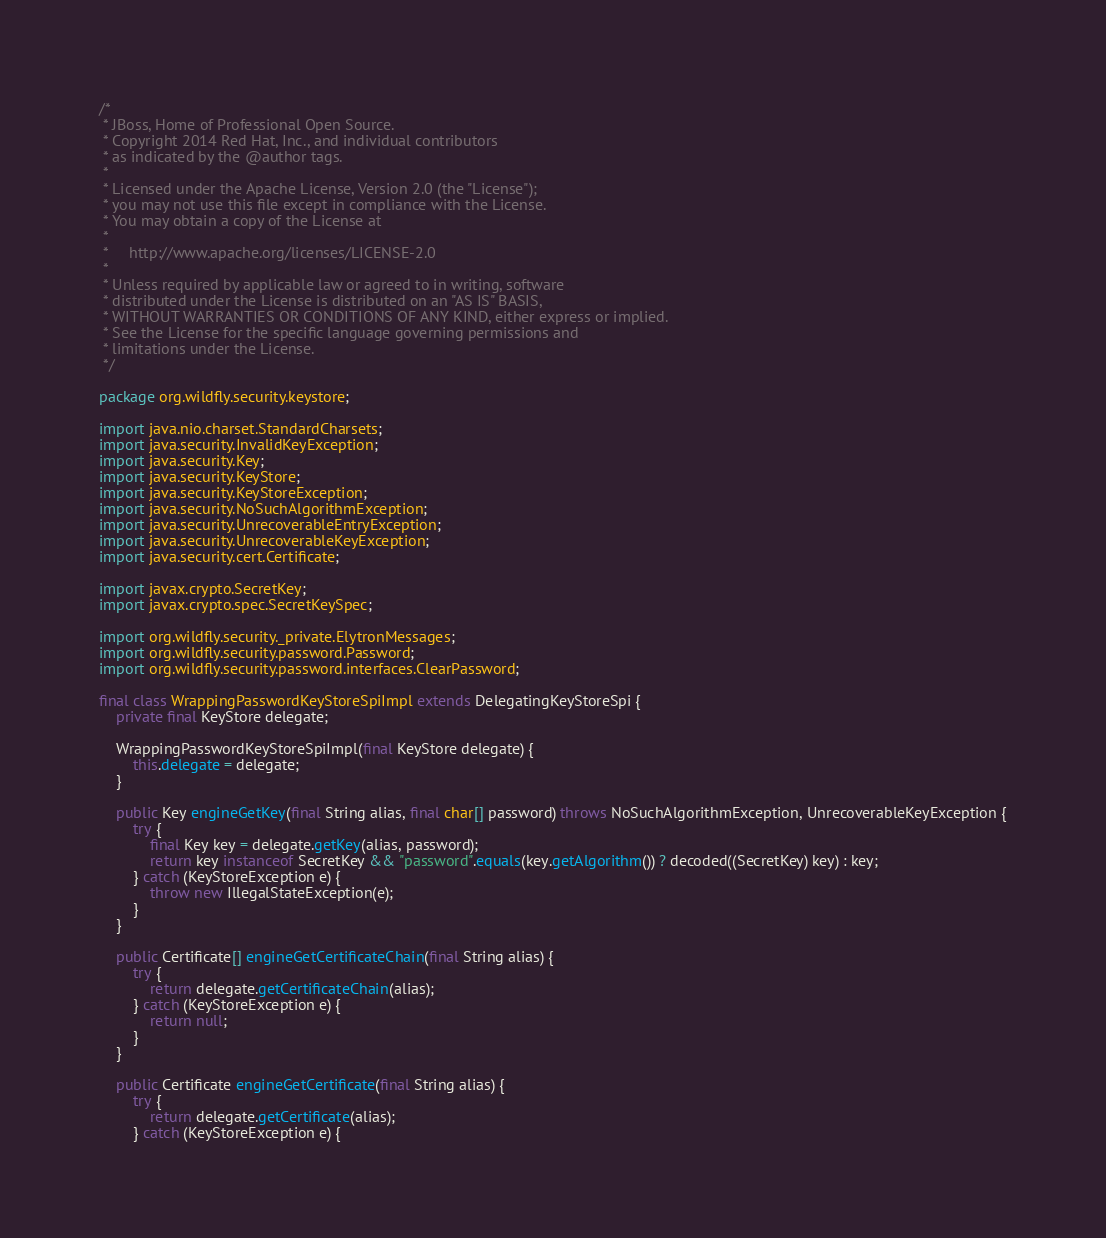<code> <loc_0><loc_0><loc_500><loc_500><_Java_>/*
 * JBoss, Home of Professional Open Source.
 * Copyright 2014 Red Hat, Inc., and individual contributors
 * as indicated by the @author tags.
 *
 * Licensed under the Apache License, Version 2.0 (the "License");
 * you may not use this file except in compliance with the License.
 * You may obtain a copy of the License at
 *
 *     http://www.apache.org/licenses/LICENSE-2.0
 *
 * Unless required by applicable law or agreed to in writing, software
 * distributed under the License is distributed on an "AS IS" BASIS,
 * WITHOUT WARRANTIES OR CONDITIONS OF ANY KIND, either express or implied.
 * See the License for the specific language governing permissions and
 * limitations under the License.
 */

package org.wildfly.security.keystore;

import java.nio.charset.StandardCharsets;
import java.security.InvalidKeyException;
import java.security.Key;
import java.security.KeyStore;
import java.security.KeyStoreException;
import java.security.NoSuchAlgorithmException;
import java.security.UnrecoverableEntryException;
import java.security.UnrecoverableKeyException;
import java.security.cert.Certificate;

import javax.crypto.SecretKey;
import javax.crypto.spec.SecretKeySpec;

import org.wildfly.security._private.ElytronMessages;
import org.wildfly.security.password.Password;
import org.wildfly.security.password.interfaces.ClearPassword;

final class WrappingPasswordKeyStoreSpiImpl extends DelegatingKeyStoreSpi {
    private final KeyStore delegate;

    WrappingPasswordKeyStoreSpiImpl(final KeyStore delegate) {
        this.delegate = delegate;
    }

    public Key engineGetKey(final String alias, final char[] password) throws NoSuchAlgorithmException, UnrecoverableKeyException {
        try {
            final Key key = delegate.getKey(alias, password);
            return key instanceof SecretKey && "password".equals(key.getAlgorithm()) ? decoded((SecretKey) key) : key;
        } catch (KeyStoreException e) {
            throw new IllegalStateException(e);
        }
    }

    public Certificate[] engineGetCertificateChain(final String alias) {
        try {
            return delegate.getCertificateChain(alias);
        } catch (KeyStoreException e) {
            return null;
        }
    }

    public Certificate engineGetCertificate(final String alias) {
        try {
            return delegate.getCertificate(alias);
        } catch (KeyStoreException e) {</code> 